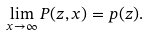Convert formula to latex. <formula><loc_0><loc_0><loc_500><loc_500>\lim _ { x \rightarrow \infty } P ( z , x ) = p ( z ) .</formula> 